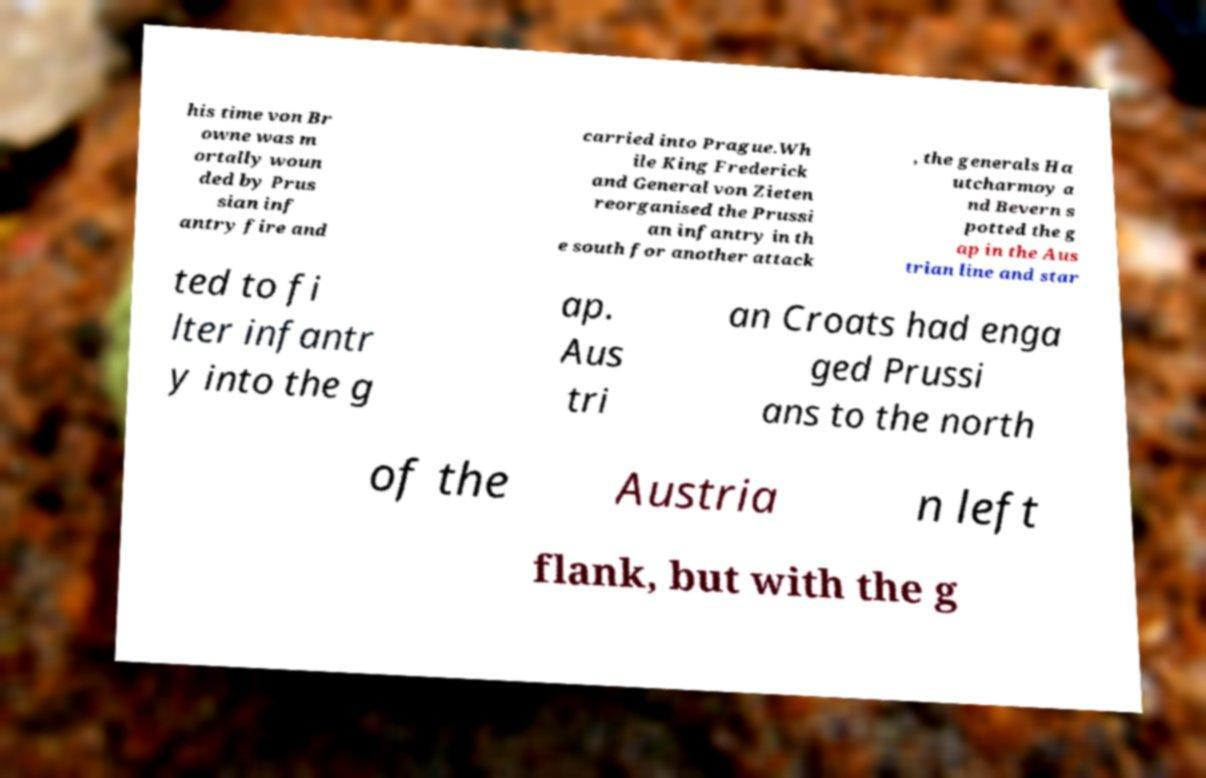There's text embedded in this image that I need extracted. Can you transcribe it verbatim? his time von Br owne was m ortally woun ded by Prus sian inf antry fire and carried into Prague.Wh ile King Frederick and General von Zieten reorganised the Prussi an infantry in th e south for another attack , the generals Ha utcharmoy a nd Bevern s potted the g ap in the Aus trian line and star ted to fi lter infantr y into the g ap. Aus tri an Croats had enga ged Prussi ans to the north of the Austria n left flank, but with the g 